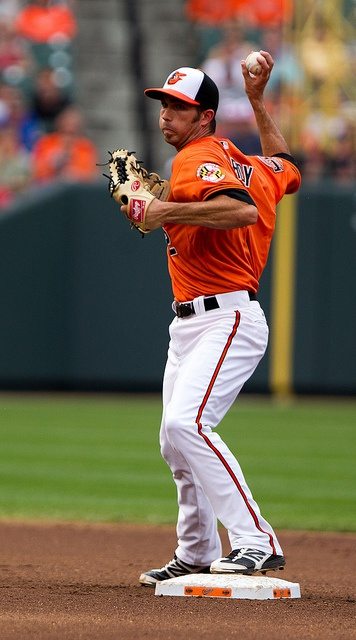Describe the objects in this image and their specific colors. I can see people in gray, lavender, maroon, and black tones, baseball glove in gray, black, tan, and beige tones, and sports ball in gray, ivory, maroon, and tan tones in this image. 